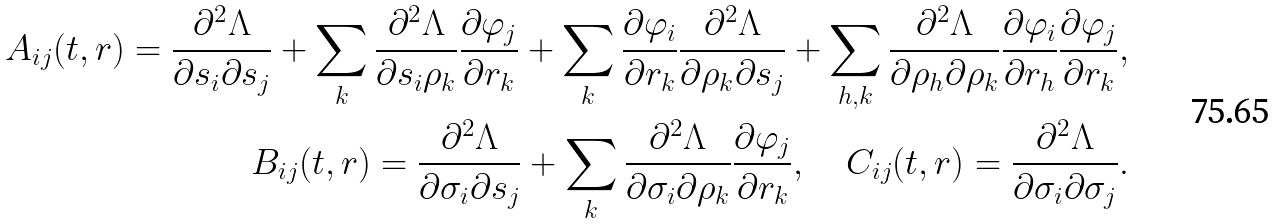Convert formula to latex. <formula><loc_0><loc_0><loc_500><loc_500>A _ { i j } ( t , r ) = \frac { \partial ^ { 2 } \Lambda } { \partial s _ { i } \partial s _ { j } } + \sum _ { k } \frac { \partial ^ { 2 } \Lambda } { \partial s _ { i } \rho _ { k } } \frac { \partial \varphi _ { j } } { \partial r _ { k } } + \sum _ { k } \frac { \partial \varphi _ { i } } { \partial r _ { k } } \frac { \partial ^ { 2 } \Lambda } { \partial \rho _ { k } \partial s _ { j } } + \sum _ { h , k } \frac { \partial ^ { 2 } \Lambda } { \partial \rho _ { h } \partial \rho _ { k } } \frac { \partial \varphi _ { i } } { \partial r _ { h } } \frac { \partial \varphi _ { j } } { \partial r _ { k } } , \\ B _ { i j } ( t , r ) = \frac { \partial ^ { 2 } \Lambda } { \partial \sigma _ { i } \partial s _ { j } } + \sum _ { k } \frac { \partial ^ { 2 } \Lambda } { \partial \sigma _ { i } \partial \rho _ { k } } \frac { \partial \varphi _ { j } } { \partial r _ { k } } , \quad C _ { i j } ( t , r ) = \frac { \partial ^ { 2 } \Lambda } { \partial \sigma _ { i } \partial \sigma _ { j } } .</formula> 